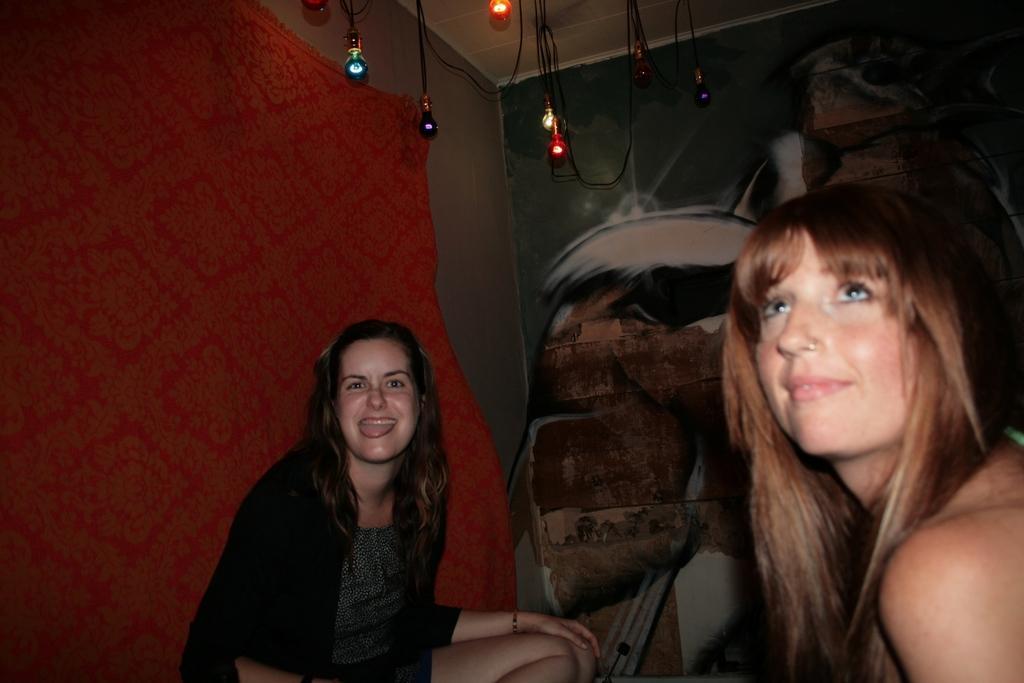Can you describe this image briefly? As we can see in the image there is wall, red color cloth and two women sitting. The woman sitting on the left side is wearing black color jacket. There is wall and there are lights. 